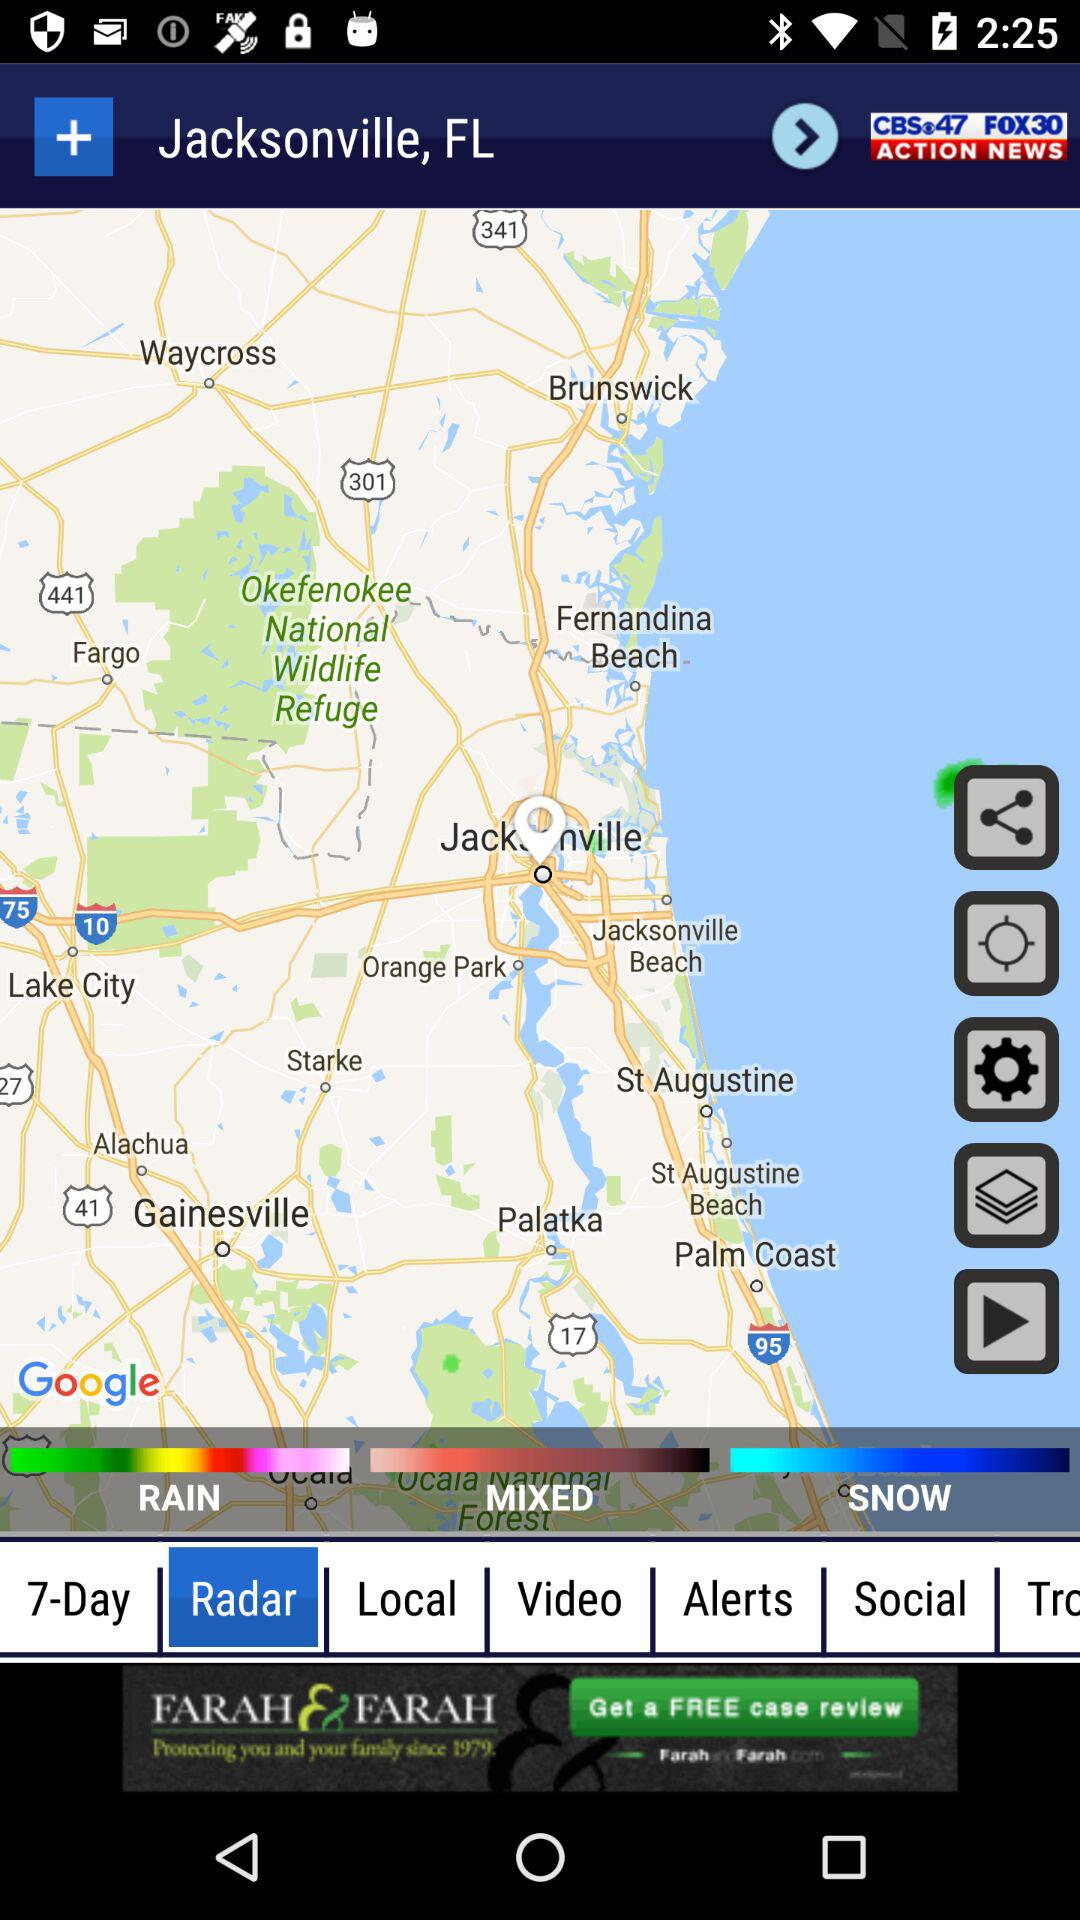How many types of weather are shown on the map?
Answer the question using a single word or phrase. 3 